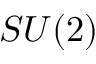<formula> <loc_0><loc_0><loc_500><loc_500>S U ( 2 )</formula> 